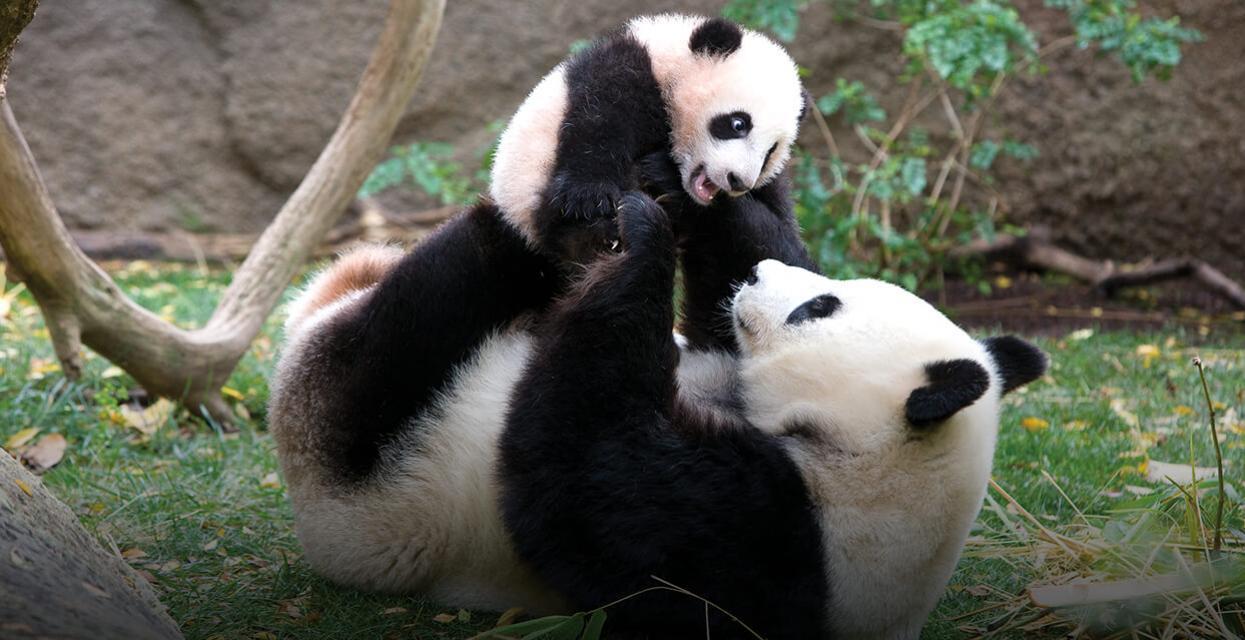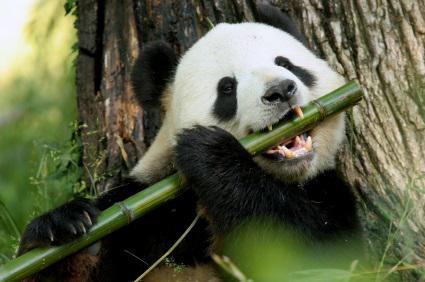The first image is the image on the left, the second image is the image on the right. Given the left and right images, does the statement "At least one of the pandas is holding onto a tree branch." hold true? Answer yes or no. No. The first image is the image on the left, the second image is the image on the right. Given the left and right images, does the statement "An image shows a panda with paws over a horizontal  tree limb." hold true? Answer yes or no. No. The first image is the image on the left, the second image is the image on the right. For the images displayed, is the sentence "An image shows a panda on its back with a smaller panda on top of it." factually correct? Answer yes or no. Yes. The first image is the image on the left, the second image is the image on the right. Given the left and right images, does the statement "A panda is playing with another panda in at least one of the images." hold true? Answer yes or no. Yes. 